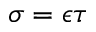<formula> <loc_0><loc_0><loc_500><loc_500>\sigma = \epsilon \tau</formula> 